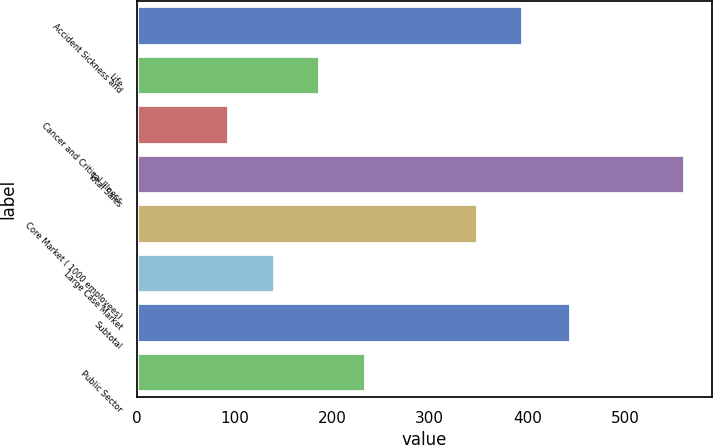Convert chart to OTSL. <chart><loc_0><loc_0><loc_500><loc_500><bar_chart><fcel>Accident Sickness and<fcel>Life<fcel>Cancer and Critical Illness<fcel>Total Sales<fcel>Core Market ( 1000 employees)<fcel>Large Case Market<fcel>Subtotal<fcel>Public Sector<nl><fcel>395.69<fcel>187.78<fcel>94.4<fcel>561.3<fcel>349<fcel>141.09<fcel>444.5<fcel>234.47<nl></chart> 